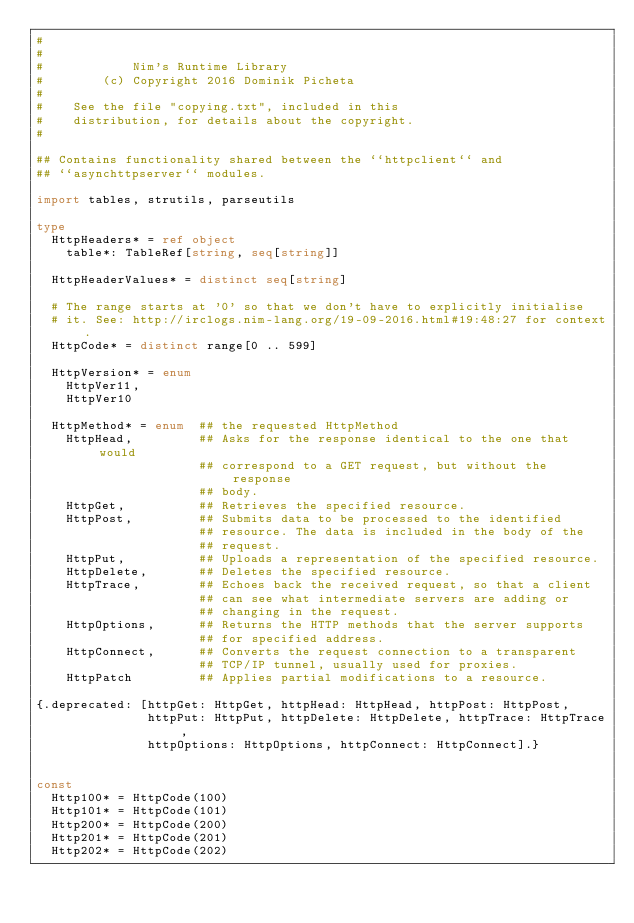Convert code to text. <code><loc_0><loc_0><loc_500><loc_500><_Nim_>#
#
#            Nim's Runtime Library
#        (c) Copyright 2016 Dominik Picheta
#
#    See the file "copying.txt", included in this
#    distribution, for details about the copyright.
#

## Contains functionality shared between the ``httpclient`` and
## ``asynchttpserver`` modules.

import tables, strutils, parseutils

type
  HttpHeaders* = ref object
    table*: TableRef[string, seq[string]]

  HttpHeaderValues* = distinct seq[string]

  # The range starts at '0' so that we don't have to explicitly initialise
  # it. See: http://irclogs.nim-lang.org/19-09-2016.html#19:48:27 for context.
  HttpCode* = distinct range[0 .. 599]

  HttpVersion* = enum
    HttpVer11,
    HttpVer10

  HttpMethod* = enum  ## the requested HttpMethod
    HttpHead,         ## Asks for the response identical to the one that would
                      ## correspond to a GET request, but without the response
                      ## body.
    HttpGet,          ## Retrieves the specified resource.
    HttpPost,         ## Submits data to be processed to the identified
                      ## resource. The data is included in the body of the
                      ## request.
    HttpPut,          ## Uploads a representation of the specified resource.
    HttpDelete,       ## Deletes the specified resource.
    HttpTrace,        ## Echoes back the received request, so that a client
                      ## can see what intermediate servers are adding or
                      ## changing in the request.
    HttpOptions,      ## Returns the HTTP methods that the server supports
                      ## for specified address.
    HttpConnect,      ## Converts the request connection to a transparent
                      ## TCP/IP tunnel, usually used for proxies.
    HttpPatch         ## Applies partial modifications to a resource.

{.deprecated: [httpGet: HttpGet, httpHead: HttpHead, httpPost: HttpPost,
               httpPut: HttpPut, httpDelete: HttpDelete, httpTrace: HttpTrace,
               httpOptions: HttpOptions, httpConnect: HttpConnect].}


const
  Http100* = HttpCode(100)
  Http101* = HttpCode(101)
  Http200* = HttpCode(200)
  Http201* = HttpCode(201)
  Http202* = HttpCode(202)</code> 